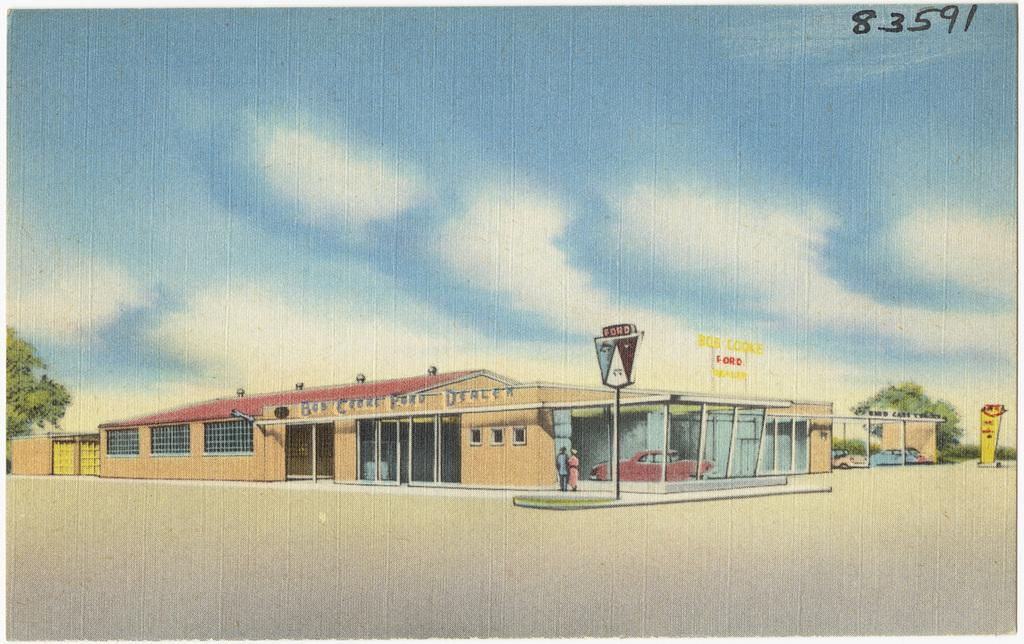<image>
Relay a brief, clear account of the picture shown. a drawing of an auto dealership, retro style, with a sign reading Bob Croke Perd Dealer over the door 